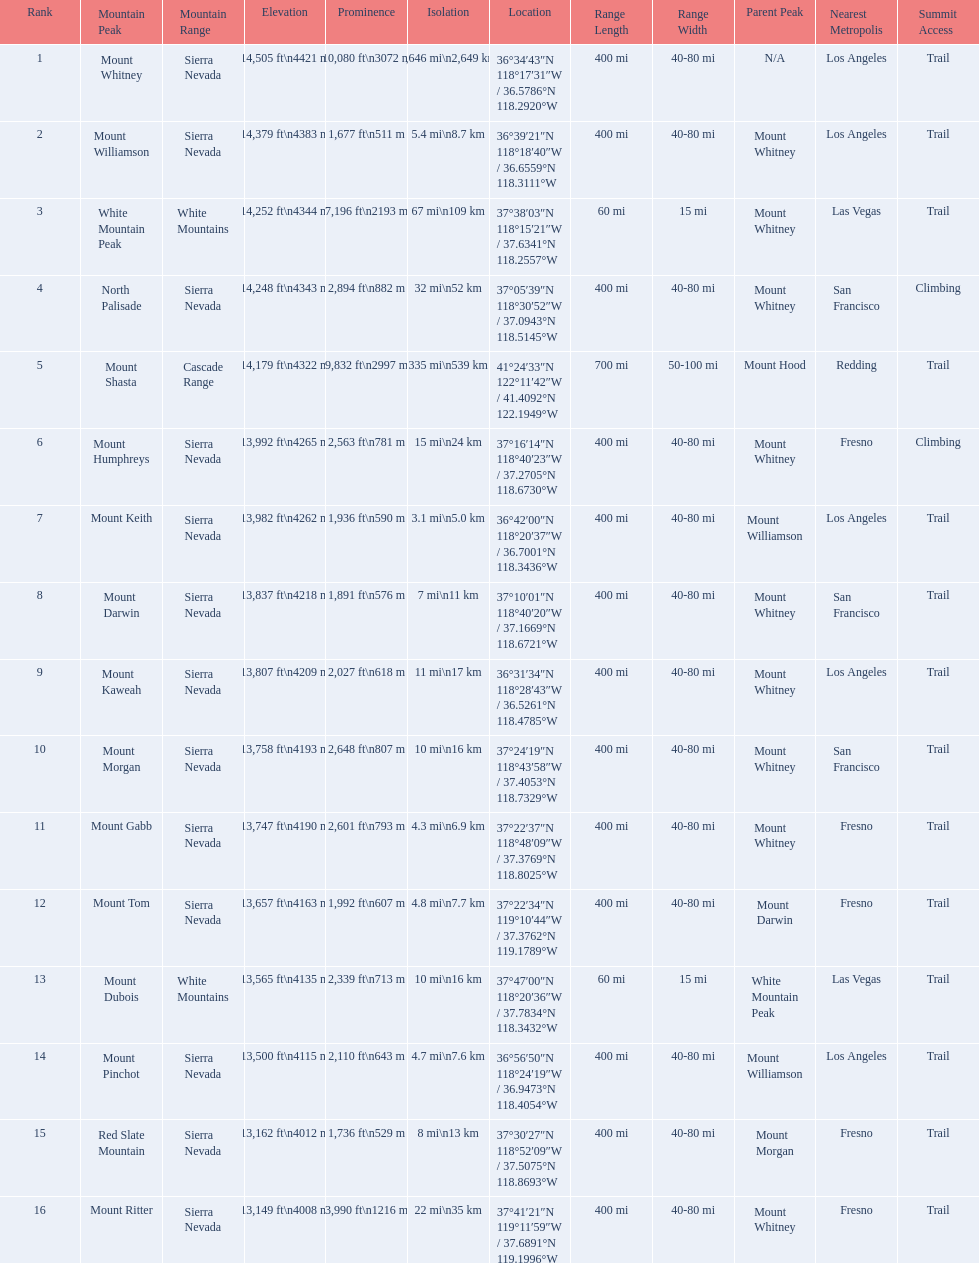What are all of the mountain peaks? Mount Whitney, Mount Williamson, White Mountain Peak, North Palisade, Mount Shasta, Mount Humphreys, Mount Keith, Mount Darwin, Mount Kaweah, Mount Morgan, Mount Gabb, Mount Tom, Mount Dubois, Mount Pinchot, Red Slate Mountain, Mount Ritter. In what ranges are they located? Sierra Nevada, Sierra Nevada, White Mountains, Sierra Nevada, Cascade Range, Sierra Nevada, Sierra Nevada, Sierra Nevada, Sierra Nevada, Sierra Nevada, Sierra Nevada, Sierra Nevada, White Mountains, Sierra Nevada, Sierra Nevada, Sierra Nevada. Could you parse the entire table? {'header': ['Rank', 'Mountain Peak', 'Mountain Range', 'Elevation', 'Prominence', 'Isolation', 'Location', 'Range Length', 'Range Width', 'Parent Peak', 'Nearest Metropolis', 'Summit Access'], 'rows': [['1', 'Mount Whitney', 'Sierra Nevada', '14,505\xa0ft\\n4421\xa0m', '10,080\xa0ft\\n3072\xa0m', '1,646\xa0mi\\n2,649\xa0km', '36°34′43″N 118°17′31″W\ufeff / \ufeff36.5786°N 118.2920°W', '400 mi', '40-80 mi', 'N/A', 'Los Angeles', 'Trail'], ['2', 'Mount Williamson', 'Sierra Nevada', '14,379\xa0ft\\n4383\xa0m', '1,677\xa0ft\\n511\xa0m', '5.4\xa0mi\\n8.7\xa0km', '36°39′21″N 118°18′40″W\ufeff / \ufeff36.6559°N 118.3111°W', '400 mi', '40-80 mi', 'Mount Whitney', 'Los Angeles', 'Trail'], ['3', 'White Mountain Peak', 'White Mountains', '14,252\xa0ft\\n4344\xa0m', '7,196\xa0ft\\n2193\xa0m', '67\xa0mi\\n109\xa0km', '37°38′03″N 118°15′21″W\ufeff / \ufeff37.6341°N 118.2557°W', '60 mi', '15 mi', 'Mount Whitney', 'Las Vegas', 'Trail'], ['4', 'North Palisade', 'Sierra Nevada', '14,248\xa0ft\\n4343\xa0m', '2,894\xa0ft\\n882\xa0m', '32\xa0mi\\n52\xa0km', '37°05′39″N 118°30′52″W\ufeff / \ufeff37.0943°N 118.5145°W', '400 mi', '40-80 mi', 'Mount Whitney', 'San Francisco', 'Climbing'], ['5', 'Mount Shasta', 'Cascade Range', '14,179\xa0ft\\n4322\xa0m', '9,832\xa0ft\\n2997\xa0m', '335\xa0mi\\n539\xa0km', '41°24′33″N 122°11′42″W\ufeff / \ufeff41.4092°N 122.1949°W', '700 mi', '50-100 mi', 'Mount Hood', 'Redding', 'Trail'], ['6', 'Mount Humphreys', 'Sierra Nevada', '13,992\xa0ft\\n4265\xa0m', '2,563\xa0ft\\n781\xa0m', '15\xa0mi\\n24\xa0km', '37°16′14″N 118°40′23″W\ufeff / \ufeff37.2705°N 118.6730°W', '400 mi', '40-80 mi', 'Mount Whitney', 'Fresno', 'Climbing'], ['7', 'Mount Keith', 'Sierra Nevada', '13,982\xa0ft\\n4262\xa0m', '1,936\xa0ft\\n590\xa0m', '3.1\xa0mi\\n5.0\xa0km', '36°42′00″N 118°20′37″W\ufeff / \ufeff36.7001°N 118.3436°W', '400 mi', '40-80 mi', 'Mount Williamson', 'Los Angeles', 'Trail'], ['8', 'Mount Darwin', 'Sierra Nevada', '13,837\xa0ft\\n4218\xa0m', '1,891\xa0ft\\n576\xa0m', '7\xa0mi\\n11\xa0km', '37°10′01″N 118°40′20″W\ufeff / \ufeff37.1669°N 118.6721°W', '400 mi', '40-80 mi', 'Mount Whitney', 'San Francisco', 'Trail'], ['9', 'Mount Kaweah', 'Sierra Nevada', '13,807\xa0ft\\n4209\xa0m', '2,027\xa0ft\\n618\xa0m', '11\xa0mi\\n17\xa0km', '36°31′34″N 118°28′43″W\ufeff / \ufeff36.5261°N 118.4785°W', '400 mi', '40-80 mi', 'Mount Whitney', 'Los Angeles', 'Trail'], ['10', 'Mount Morgan', 'Sierra Nevada', '13,758\xa0ft\\n4193\xa0m', '2,648\xa0ft\\n807\xa0m', '10\xa0mi\\n16\xa0km', '37°24′19″N 118°43′58″W\ufeff / \ufeff37.4053°N 118.7329°W', '400 mi', '40-80 mi', 'Mount Whitney', 'San Francisco', 'Trail'], ['11', 'Mount Gabb', 'Sierra Nevada', '13,747\xa0ft\\n4190\xa0m', '2,601\xa0ft\\n793\xa0m', '4.3\xa0mi\\n6.9\xa0km', '37°22′37″N 118°48′09″W\ufeff / \ufeff37.3769°N 118.8025°W', '400 mi', '40-80 mi', 'Mount Whitney', 'Fresno', 'Trail'], ['12', 'Mount Tom', 'Sierra Nevada', '13,657\xa0ft\\n4163\xa0m', '1,992\xa0ft\\n607\xa0m', '4.8\xa0mi\\n7.7\xa0km', '37°22′34″N 119°10′44″W\ufeff / \ufeff37.3762°N 119.1789°W', '400 mi', '40-80 mi', 'Mount Darwin', 'Fresno', 'Trail'], ['13', 'Mount Dubois', 'White Mountains', '13,565\xa0ft\\n4135\xa0m', '2,339\xa0ft\\n713\xa0m', '10\xa0mi\\n16\xa0km', '37°47′00″N 118°20′36″W\ufeff / \ufeff37.7834°N 118.3432°W', '60 mi', '15 mi', 'White Mountain Peak', 'Las Vegas', 'Trail'], ['14', 'Mount Pinchot', 'Sierra Nevada', '13,500\xa0ft\\n4115\xa0m', '2,110\xa0ft\\n643\xa0m', '4.7\xa0mi\\n7.6\xa0km', '36°56′50″N 118°24′19″W\ufeff / \ufeff36.9473°N 118.4054°W', '400 mi', '40-80 mi', 'Mount Williamson', 'Los Angeles', 'Trail'], ['15', 'Red Slate Mountain', 'Sierra Nevada', '13,162\xa0ft\\n4012\xa0m', '1,736\xa0ft\\n529\xa0m', '8\xa0mi\\n13\xa0km', '37°30′27″N 118°52′09″W\ufeff / \ufeff37.5075°N 118.8693°W', '400 mi', '40-80 mi', 'Mount Morgan', 'Fresno', 'Trail'], ['16', 'Mount Ritter', 'Sierra Nevada', '13,149\xa0ft\\n4008\xa0m', '3,990\xa0ft\\n1216\xa0m', '22\xa0mi\\n35\xa0km', '37°41′21″N 119°11′59″W\ufeff / \ufeff37.6891°N 119.1996°W', '400 mi', '40-80 mi', 'Mount Whitney', 'Fresno', 'Trail']]} And which mountain peak is in the cascade range? Mount Shasta. 